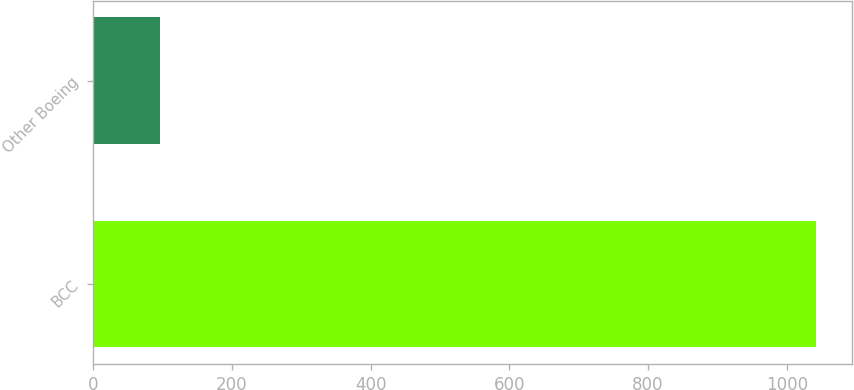<chart> <loc_0><loc_0><loc_500><loc_500><bar_chart><fcel>BCC<fcel>Other Boeing<nl><fcel>1042<fcel>96<nl></chart> 